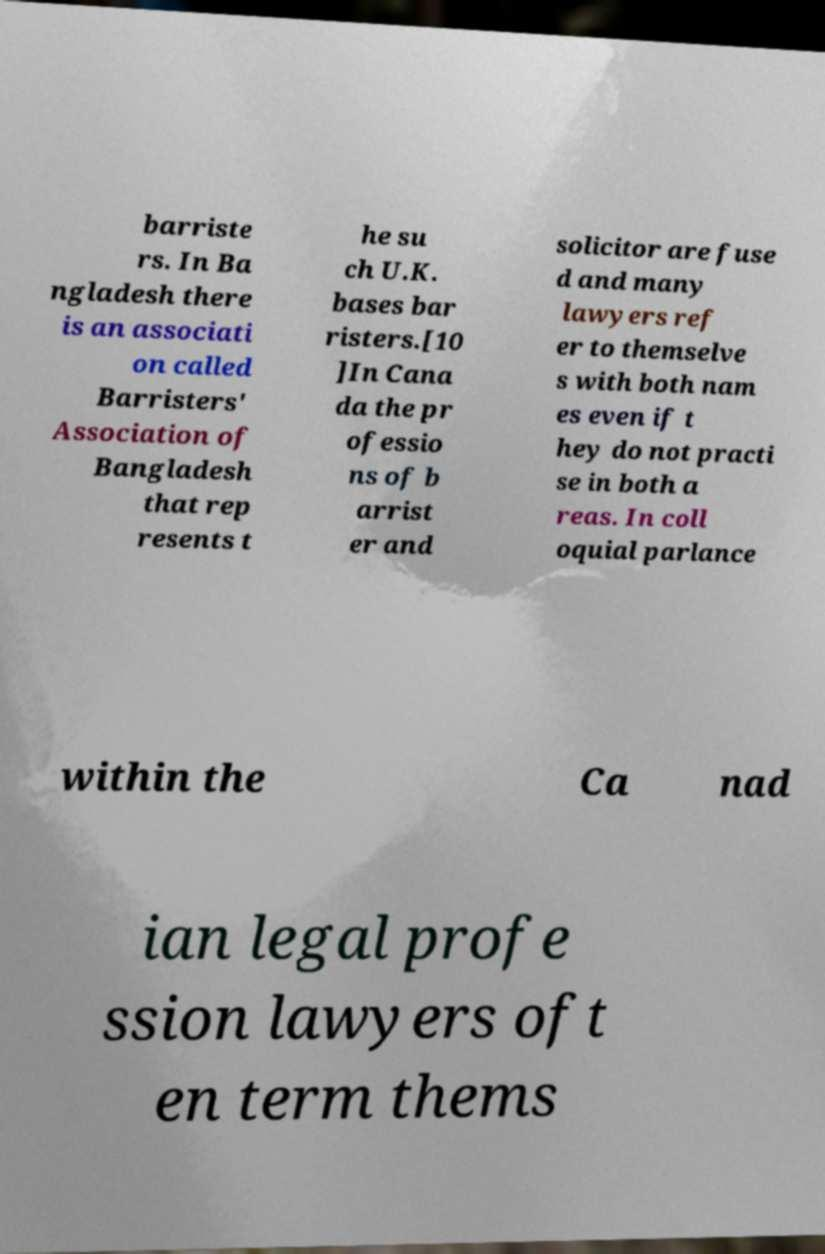Can you read and provide the text displayed in the image?This photo seems to have some interesting text. Can you extract and type it out for me? barriste rs. In Ba ngladesh there is an associati on called Barristers' Association of Bangladesh that rep resents t he su ch U.K. bases bar risters.[10 ]In Cana da the pr ofessio ns of b arrist er and solicitor are fuse d and many lawyers ref er to themselve s with both nam es even if t hey do not practi se in both a reas. In coll oquial parlance within the Ca nad ian legal profe ssion lawyers oft en term thems 